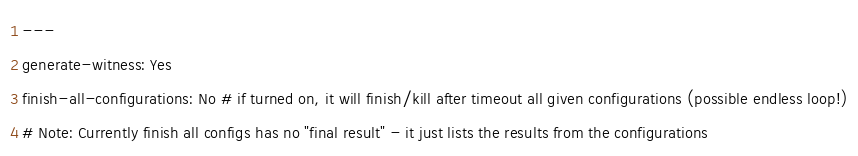<code> <loc_0><loc_0><loc_500><loc_500><_YAML_>---
generate-witness: Yes
finish-all-configurations: No # if turned on, it will finish/kill after timeout all given configurations (possible endless loop!)
# Note: Currently finish all configs has no "final result" - it just lists the results from the configurations
</code> 